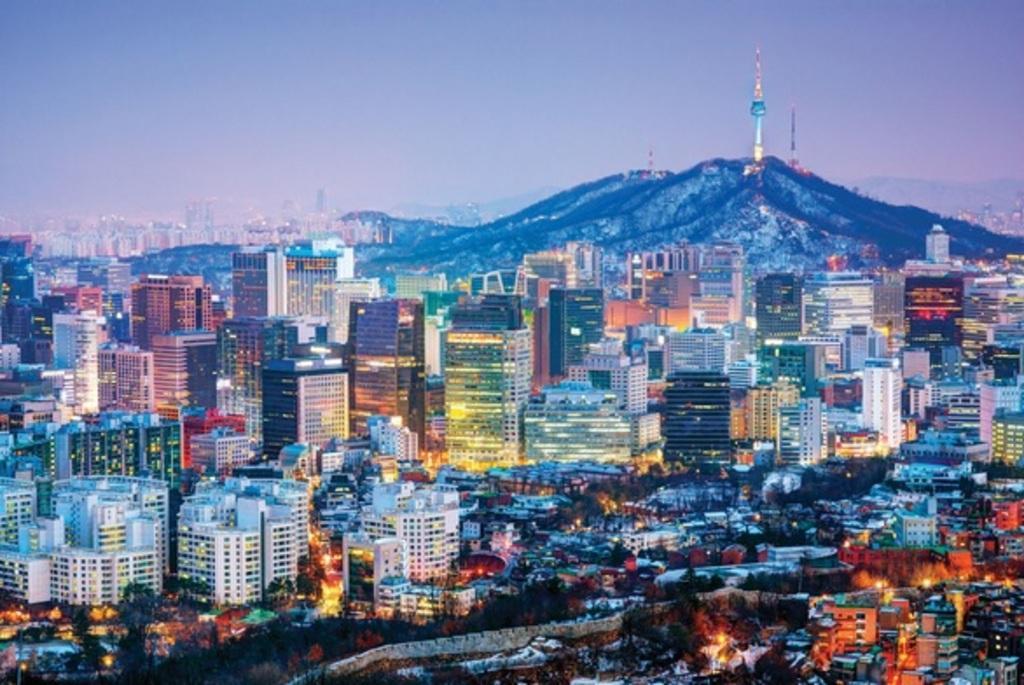Please provide a concise description of this image. In this image I can see number of buildings which are colorful, the wall, few trees and few lights. In the background I can see few mountains, few towers, few buildings and the sky. 